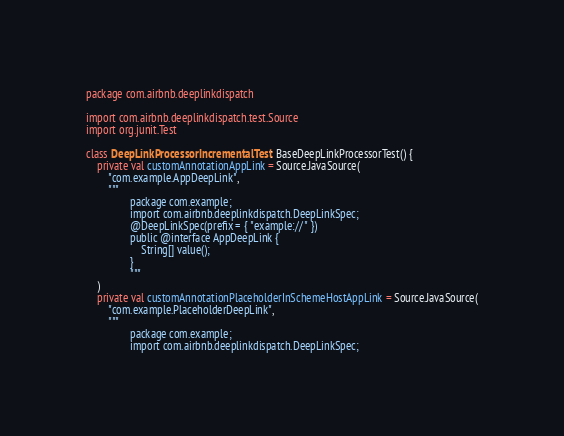<code> <loc_0><loc_0><loc_500><loc_500><_Kotlin_>package com.airbnb.deeplinkdispatch

import com.airbnb.deeplinkdispatch.test.Source
import org.junit.Test

class DeepLinkProcessorIncrementalTest : BaseDeepLinkProcessorTest() {
    private val customAnnotationAppLink = Source.JavaSource(
        "com.example.AppDeepLink",
        """
                package com.example;
                import com.airbnb.deeplinkdispatch.DeepLinkSpec;
                @DeepLinkSpec(prefix = { "example://" })
                public @interface AppDeepLink {
                    String[] value();
                }
                """
    )
    private val customAnnotationPlaceholderInSchemeHostAppLink = Source.JavaSource(
        "com.example.PlaceholderDeepLink",
        """
                package com.example;
                import com.airbnb.deeplinkdispatch.DeepLinkSpec;</code> 